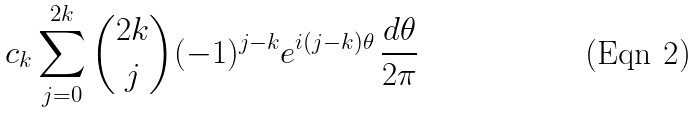<formula> <loc_0><loc_0><loc_500><loc_500>c _ { k } \sum _ { j = 0 } ^ { 2 k } \binom { 2 k } { j } ( - 1 ) ^ { j - k } e ^ { i ( j - k ) \theta } \, \frac { d \theta } { 2 \pi }</formula> 